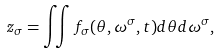<formula> <loc_0><loc_0><loc_500><loc_500>z _ { \sigma } = \iint f _ { \sigma } ( \theta , \omega ^ { \sigma } , t ) d \theta d \omega ^ { \sigma } ,</formula> 